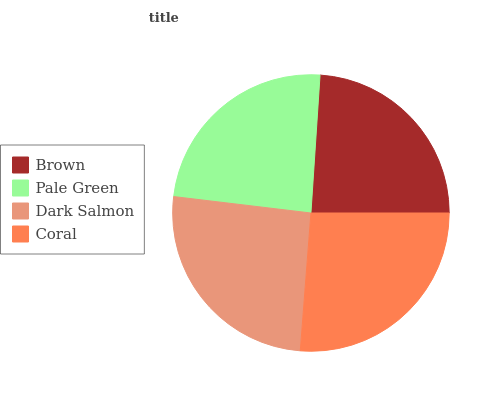Is Brown the minimum?
Answer yes or no. Yes. Is Coral the maximum?
Answer yes or no. Yes. Is Pale Green the minimum?
Answer yes or no. No. Is Pale Green the maximum?
Answer yes or no. No. Is Pale Green greater than Brown?
Answer yes or no. Yes. Is Brown less than Pale Green?
Answer yes or no. Yes. Is Brown greater than Pale Green?
Answer yes or no. No. Is Pale Green less than Brown?
Answer yes or no. No. Is Dark Salmon the high median?
Answer yes or no. Yes. Is Pale Green the low median?
Answer yes or no. Yes. Is Pale Green the high median?
Answer yes or no. No. Is Dark Salmon the low median?
Answer yes or no. No. 